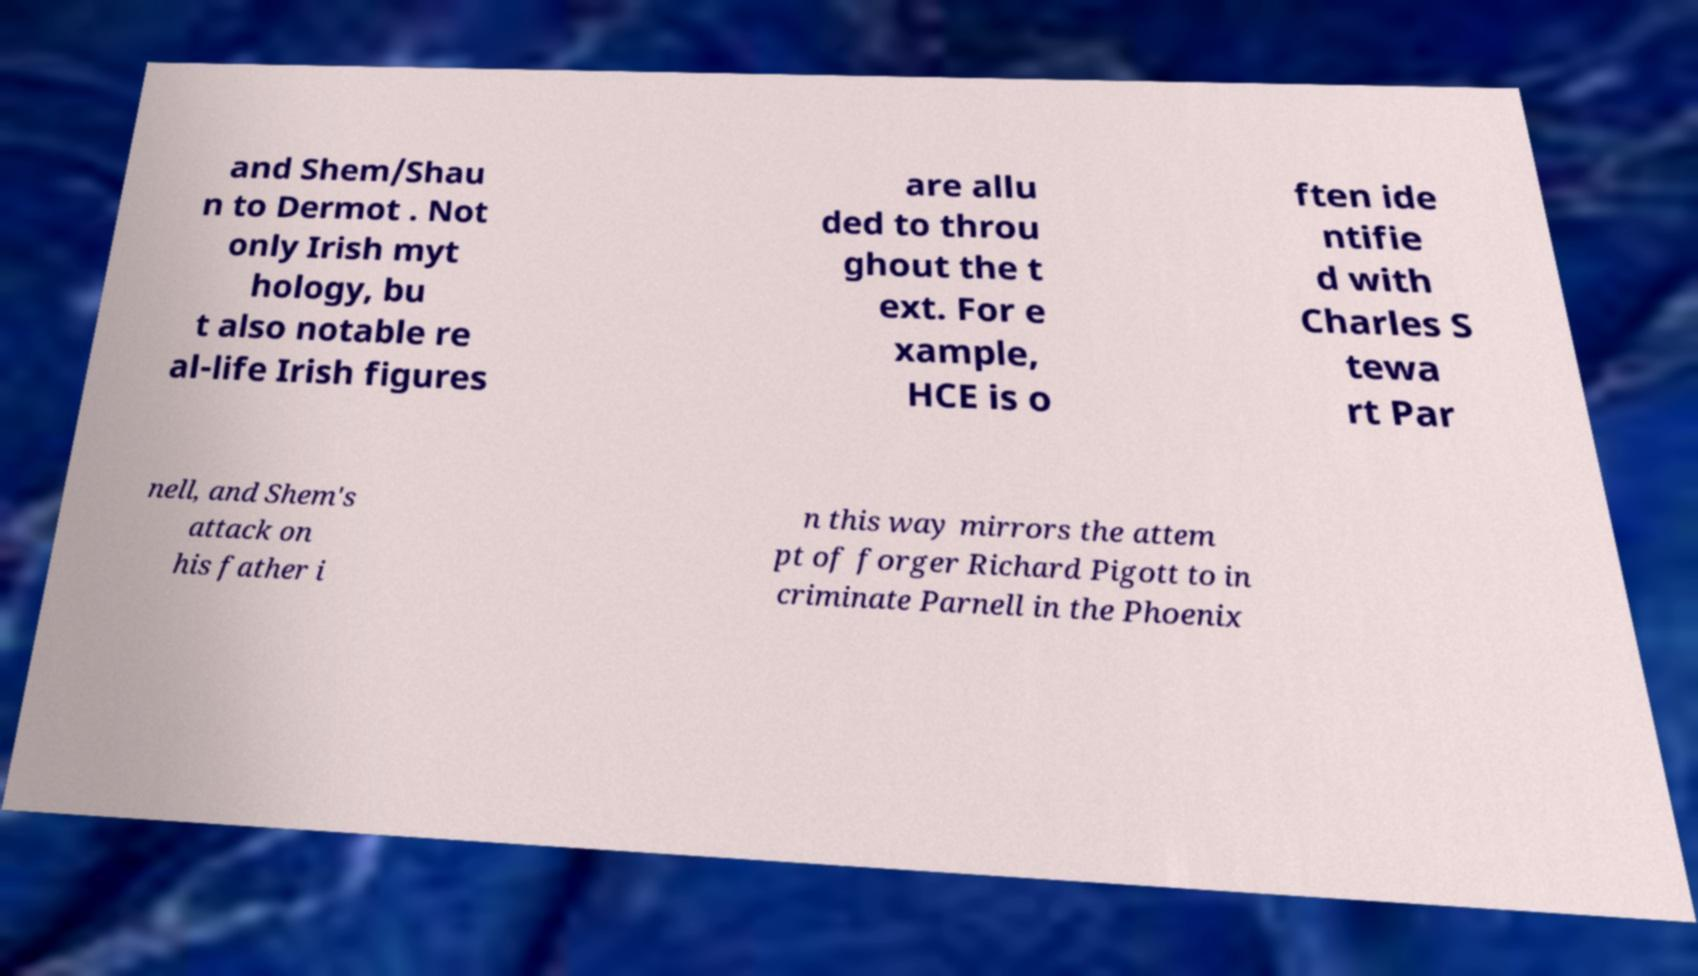Can you accurately transcribe the text from the provided image for me? and Shem/Shau n to Dermot . Not only Irish myt hology, bu t also notable re al-life Irish figures are allu ded to throu ghout the t ext. For e xample, HCE is o ften ide ntifie d with Charles S tewa rt Par nell, and Shem's attack on his father i n this way mirrors the attem pt of forger Richard Pigott to in criminate Parnell in the Phoenix 